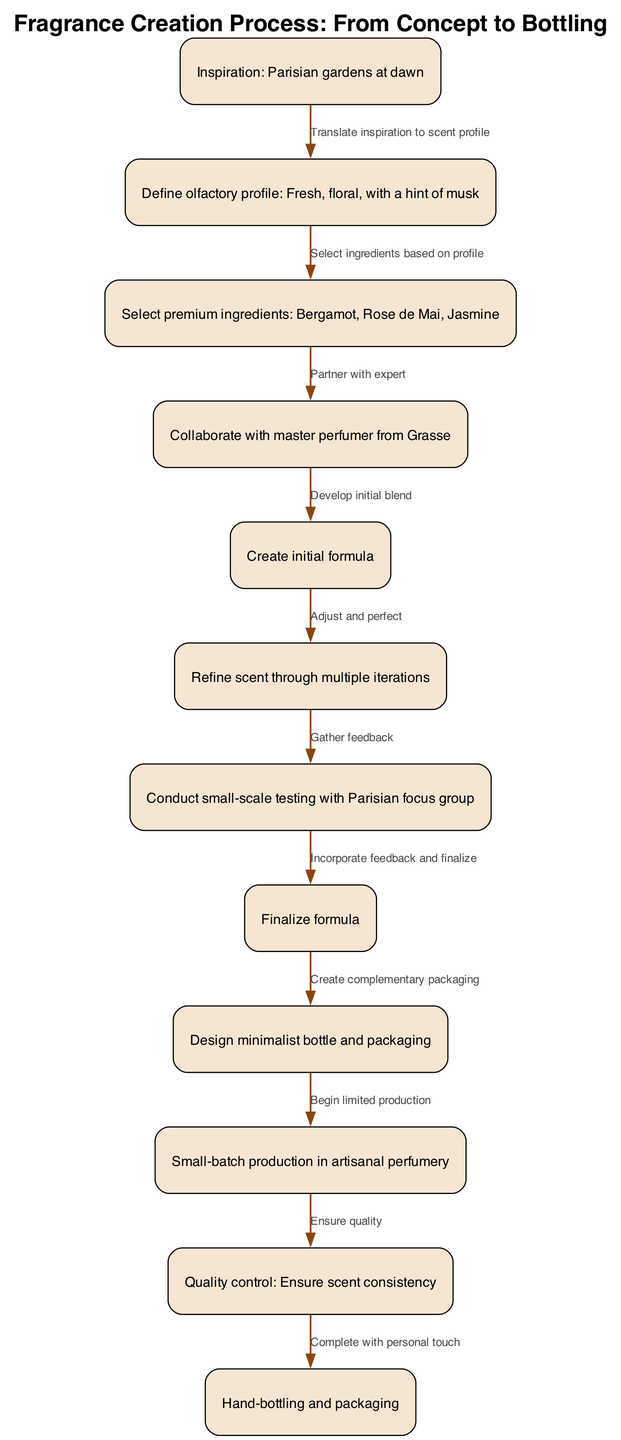What is the inspiration for the fragrance creation? The first node in the diagram indicates that the inspiration comes from "Parisian gardens at dawn." This is the initial step, which directly influences the entire fragrance development process.
Answer: Parisian gardens at dawn How many nodes are there in the diagram? By counting the nodes listed in the data, there are a total of 12 nodes representing different steps in the fragrance creation process.
Answer: 12 What type of scent is defined in the olfactory profile? The second node describes the olfactory profile as "Fresh, floral, with a hint of musk." This defines the characteristics of the scent being created.
Answer: Fresh, floral, with a hint of musk Which node comes immediately after selecting premium ingredients? According to the edges, after selecting premium ingredients (node 3), the next step is to "Collaborate with master perfumer from Grasse" (node 4). This step signifies a crucial partnership in the fragrance development.
Answer: Collaborate with master perfumer from Grasse What final action is taken after ensuring quality? The last node in the diagram shows that the final action taken is "Hand-bottling and packaging." This emphasizes the personal touch in the finalization of the product before it reaches consumers.
Answer: Hand-bottling and packaging Which step involves feedback gathering? The seventh node indicates that this step is "Conduct small-scale testing with Parisian focus group." This step is crucial for evaluating the scent against consumer preferences before finalizing the formula.
Answer: Conduct small-scale testing with Parisian focus group What action follows the creation of the final formula? After the final formula is established (node 8), the next action is to "Design minimalist bottle and packaging" (node 9). This highlights the importance of aesthetics in the final product.
Answer: Design minimalist bottle and packaging How does inspiration translate into the fragrance development process? The first edge leads from node 1 to node 2, with the text "Translate inspiration to scent profile." This indicates that the essence of the inspiration is utilized to define the olfactory profile for the fragrance.
Answer: Translate inspiration to scent profile What does the collaboration with the master perfumer lead to? The flow from node 4 to node 5 shows that collaborating with the expert leads to the development of the "initial blend," which marks the transition from concept to actual formulation.
Answer: Develop initial blend 